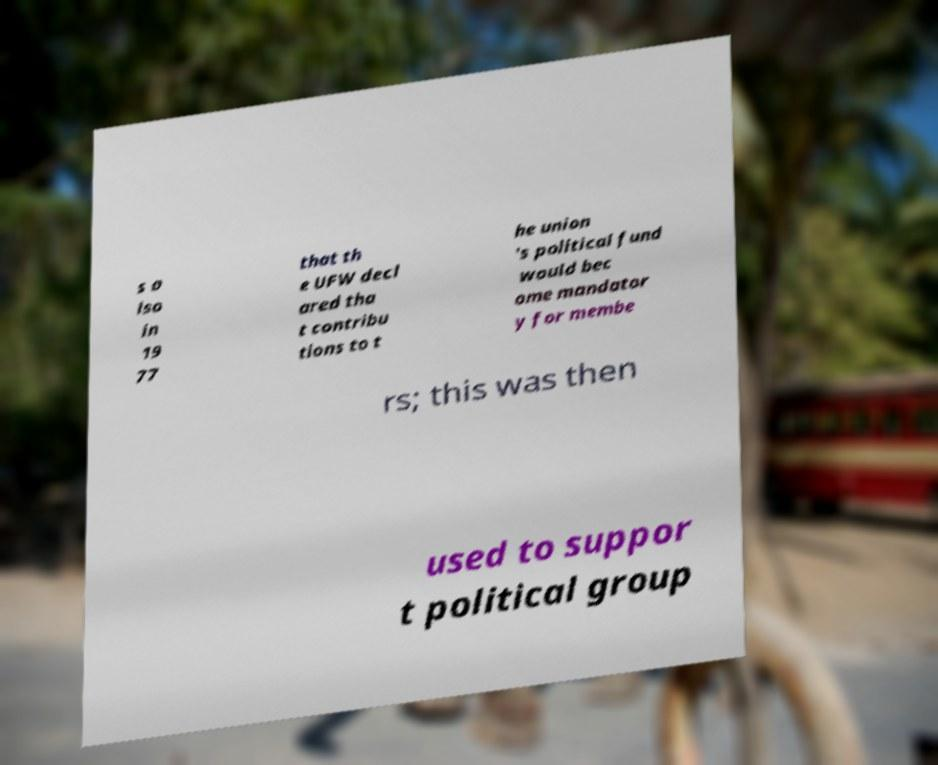For documentation purposes, I need the text within this image transcribed. Could you provide that? s a lso in 19 77 that th e UFW decl ared tha t contribu tions to t he union 's political fund would bec ome mandator y for membe rs; this was then used to suppor t political group 